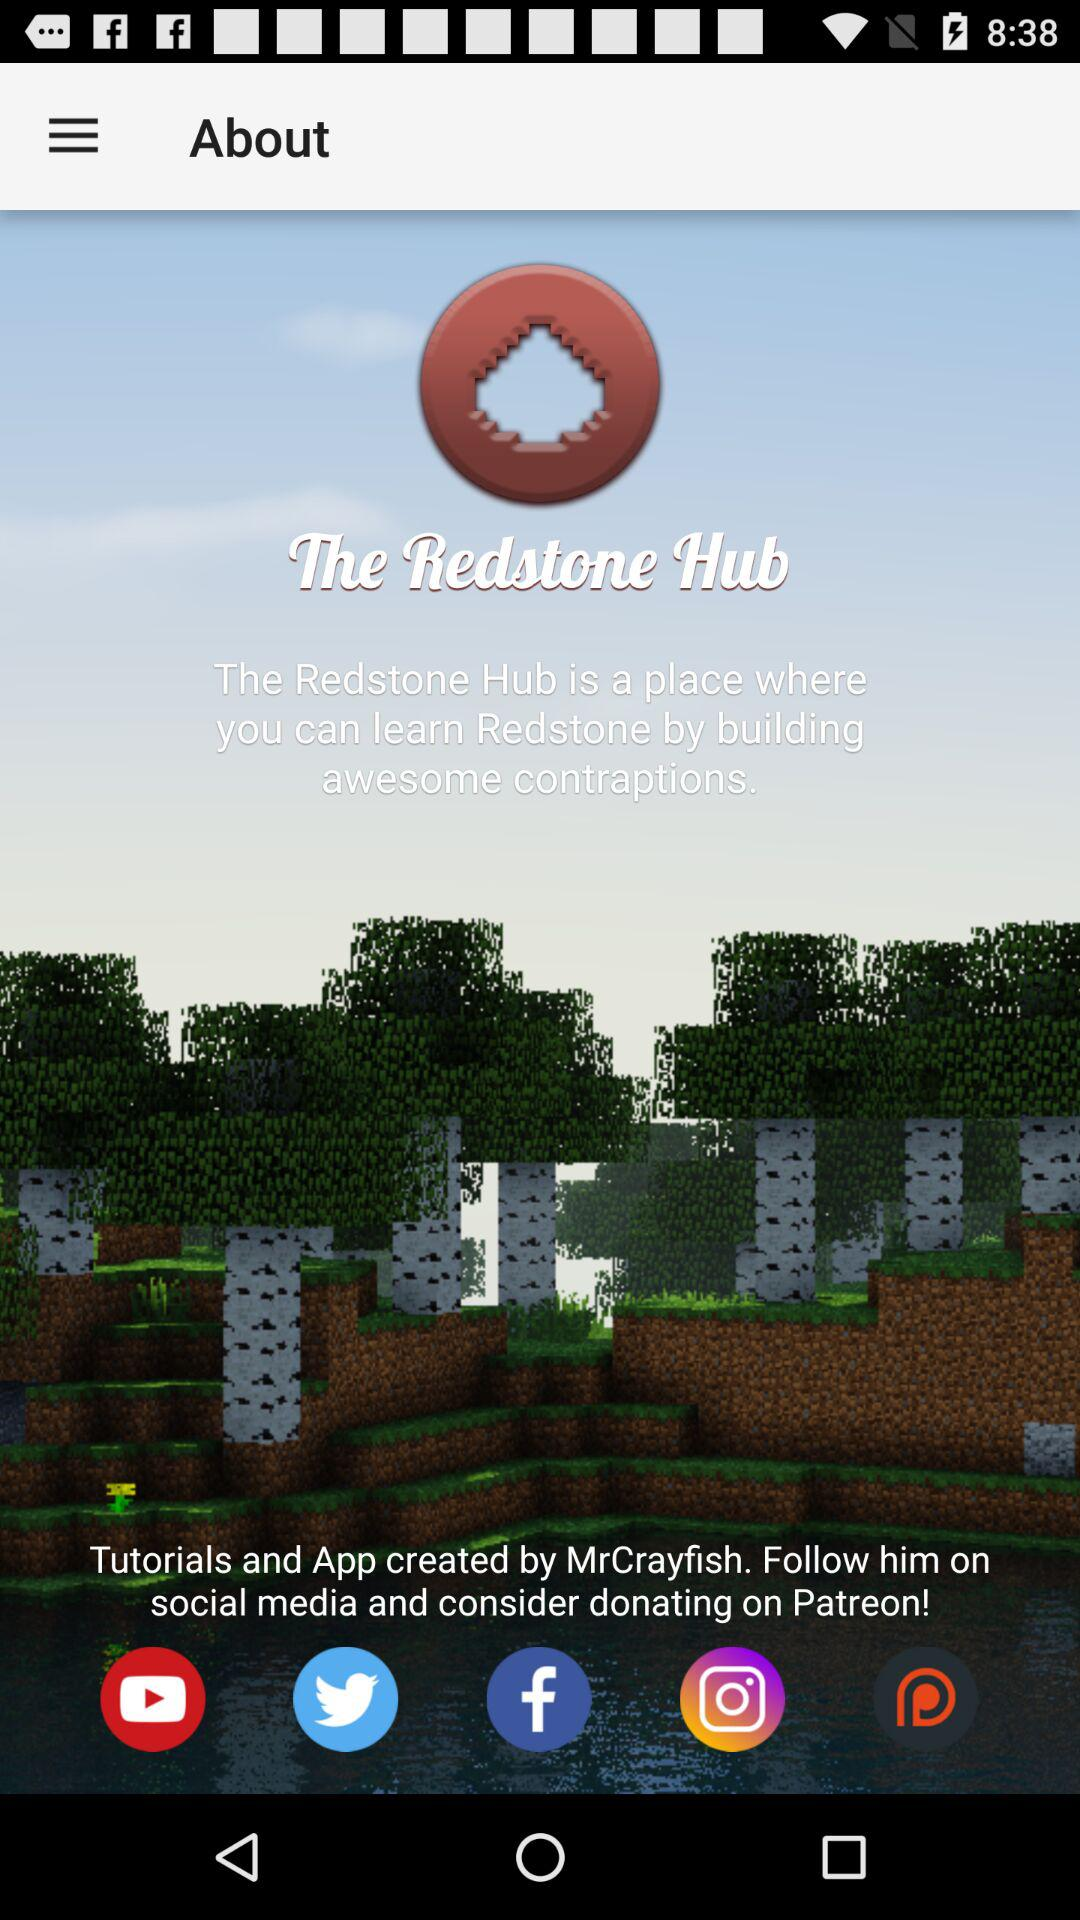What is the name of the application? The name of the application is "The Redstone Hub". 